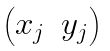Convert formula to latex. <formula><loc_0><loc_0><loc_500><loc_500>\begin{pmatrix} x _ { j } & y _ { j } \end{pmatrix}</formula> 